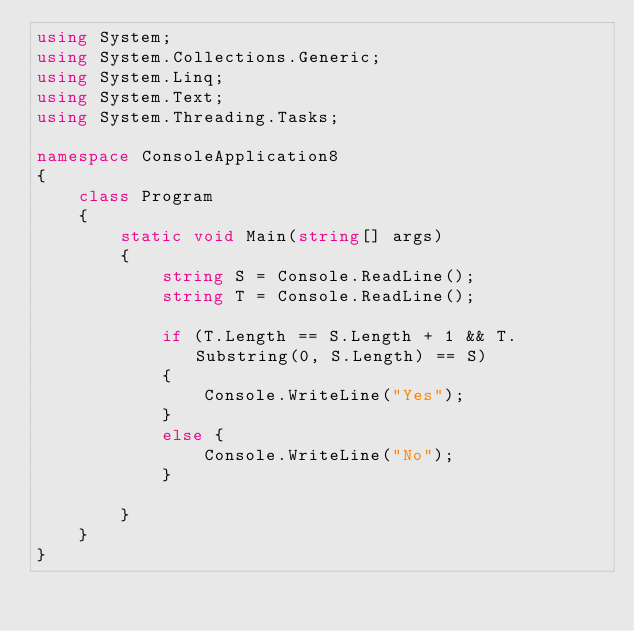Convert code to text. <code><loc_0><loc_0><loc_500><loc_500><_C#_>using System;
using System.Collections.Generic;
using System.Linq;
using System.Text;
using System.Threading.Tasks;

namespace ConsoleApplication8
{
    class Program
    {
        static void Main(string[] args)
        {
            string S = Console.ReadLine();
            string T = Console.ReadLine();

            if (T.Length == S.Length + 1 && T.Substring(0, S.Length) == S)
            {
                Console.WriteLine("Yes");
            }
            else {
                Console.WriteLine("No");
            }

        }
    }
}
</code> 